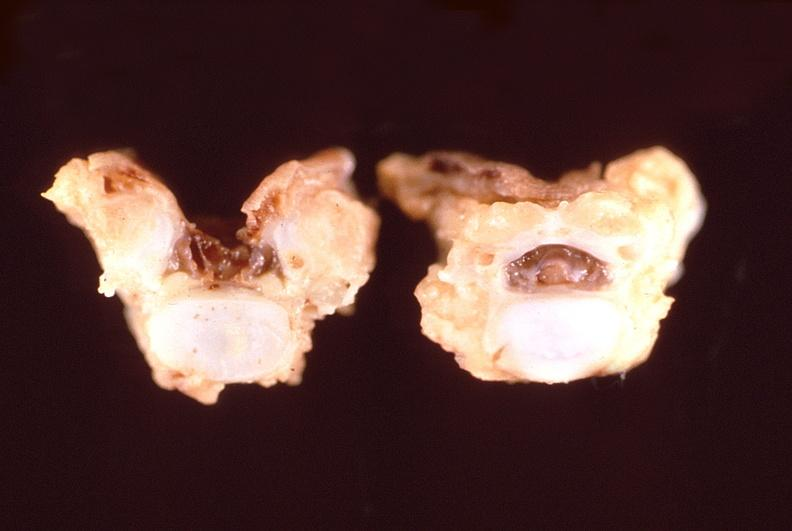what does this image show?
Answer the question using a single word or phrase. Neural tube defect 